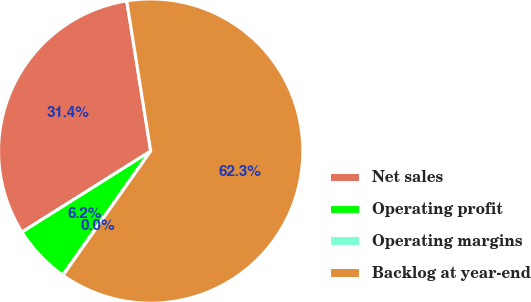Convert chart. <chart><loc_0><loc_0><loc_500><loc_500><pie_chart><fcel>Net sales<fcel>Operating profit<fcel>Operating margins<fcel>Backlog at year-end<nl><fcel>31.42%<fcel>6.25%<fcel>0.03%<fcel>62.3%<nl></chart> 